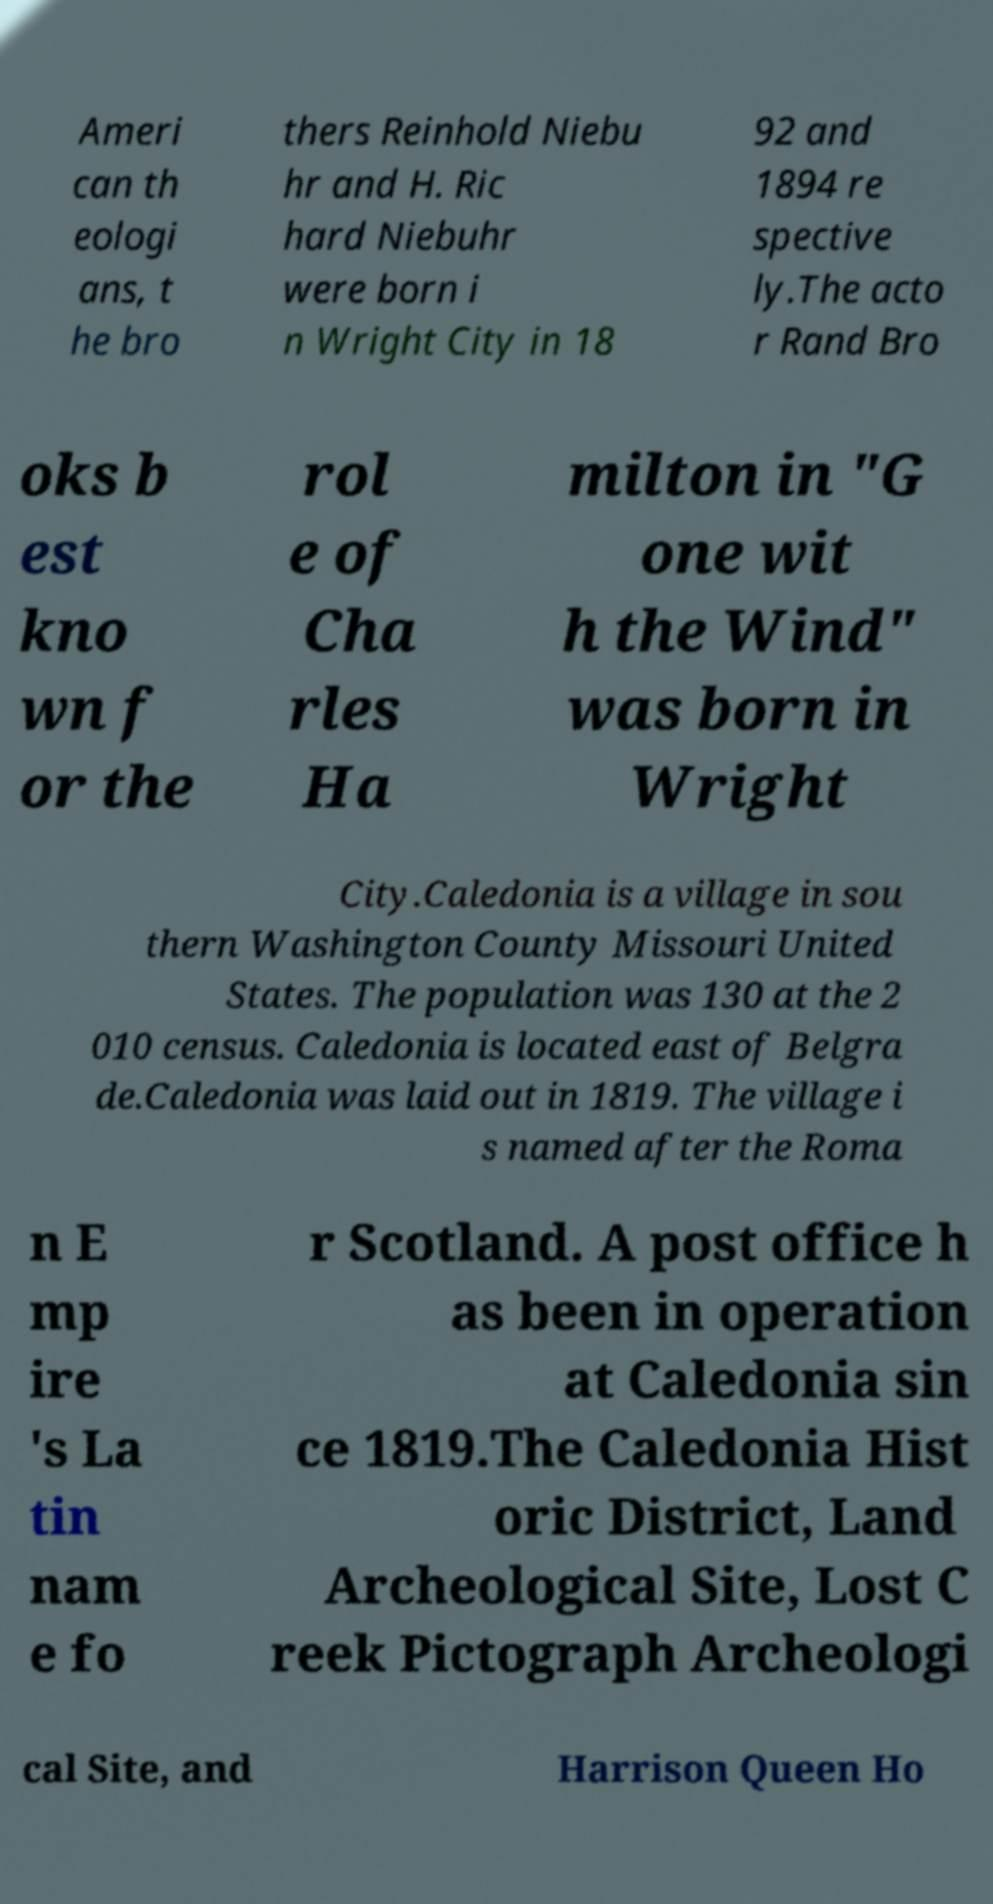Please identify and transcribe the text found in this image. Ameri can th eologi ans, t he bro thers Reinhold Niebu hr and H. Ric hard Niebuhr were born i n Wright City in 18 92 and 1894 re spective ly.The acto r Rand Bro oks b est kno wn f or the rol e of Cha rles Ha milton in "G one wit h the Wind" was born in Wright City.Caledonia is a village in sou thern Washington County Missouri United States. The population was 130 at the 2 010 census. Caledonia is located east of Belgra de.Caledonia was laid out in 1819. The village i s named after the Roma n E mp ire 's La tin nam e fo r Scotland. A post office h as been in operation at Caledonia sin ce 1819.The Caledonia Hist oric District, Land Archeological Site, Lost C reek Pictograph Archeologi cal Site, and Harrison Queen Ho 